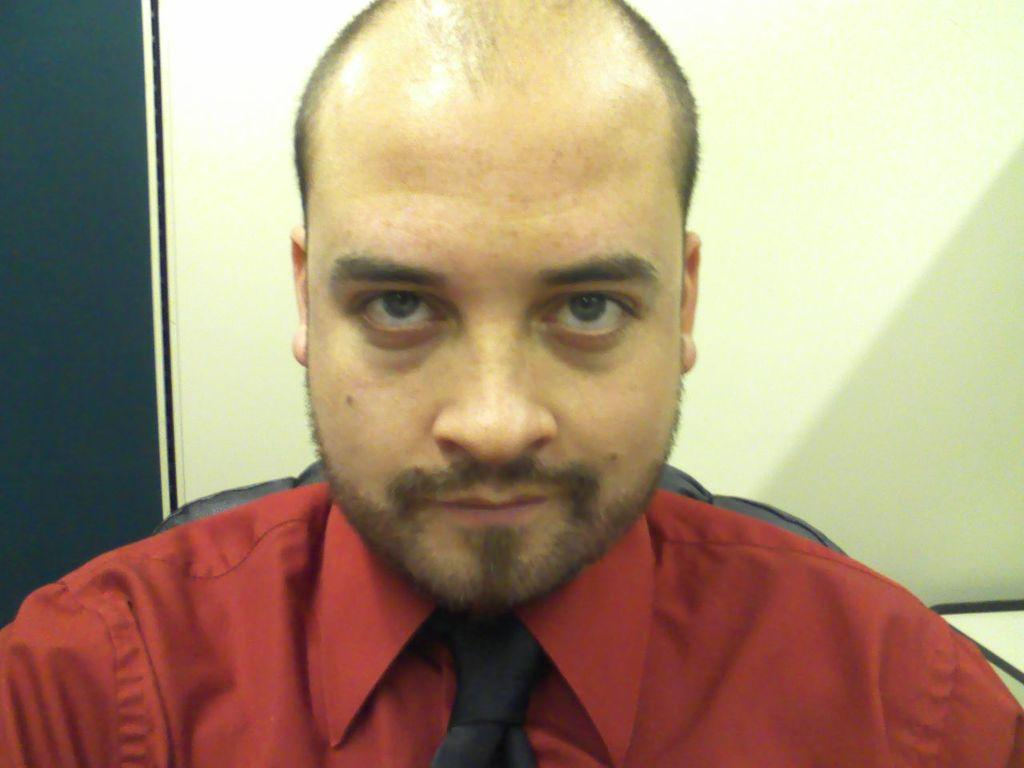Who is present in the image? There is a man in the image. What is the man doing in the image? The man is sitting in a chair. What is the man wearing in the image? The man is wearing a red shirt and a tie. What can be seen behind the man in the image? There is a wall behind the man. What type of bone is visible in the man's hand in the image? There is no bone visible in the man's hand in the image. What route is the man taking in the image? The image does not depict the man taking any route, as he is sitting in a chair. 